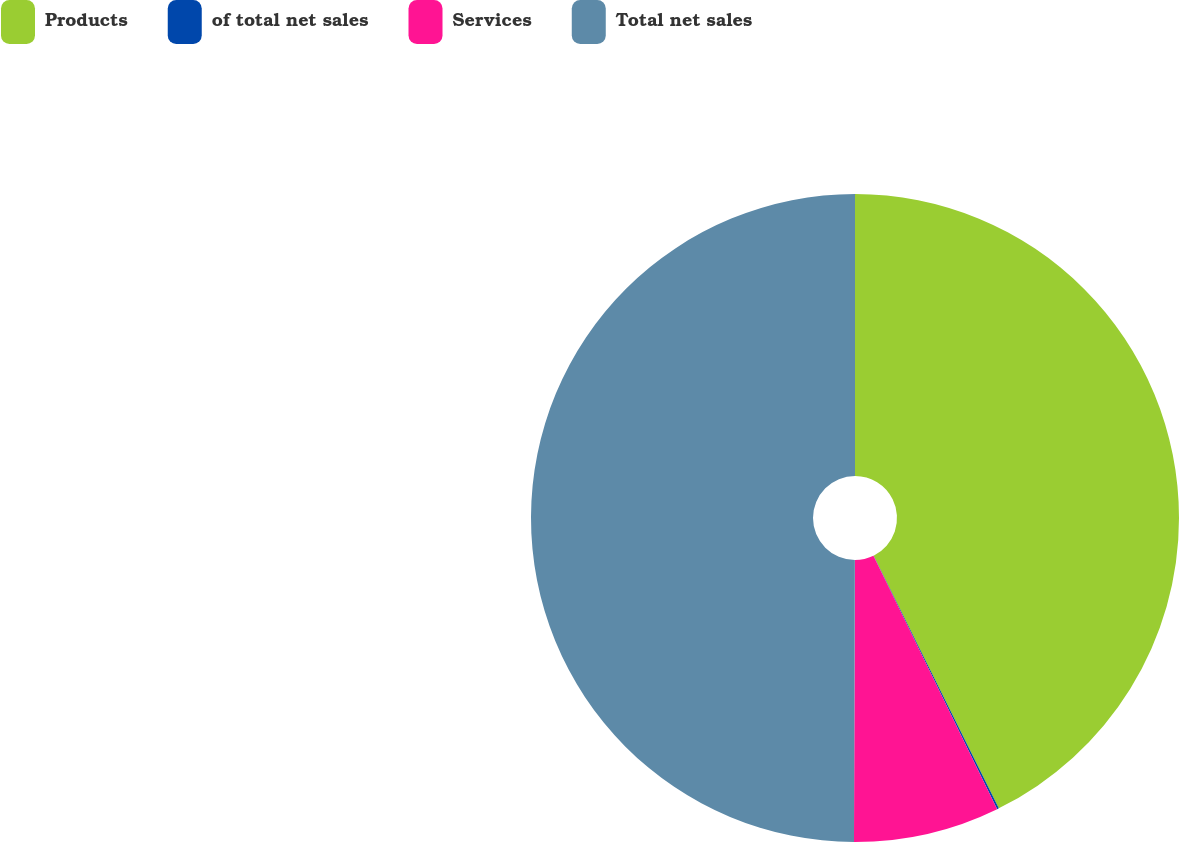<chart> <loc_0><loc_0><loc_500><loc_500><pie_chart><fcel>Products<fcel>of total net sales<fcel>Services<fcel>Total net sales<nl><fcel>42.68%<fcel>0.09%<fcel>7.28%<fcel>49.95%<nl></chart> 